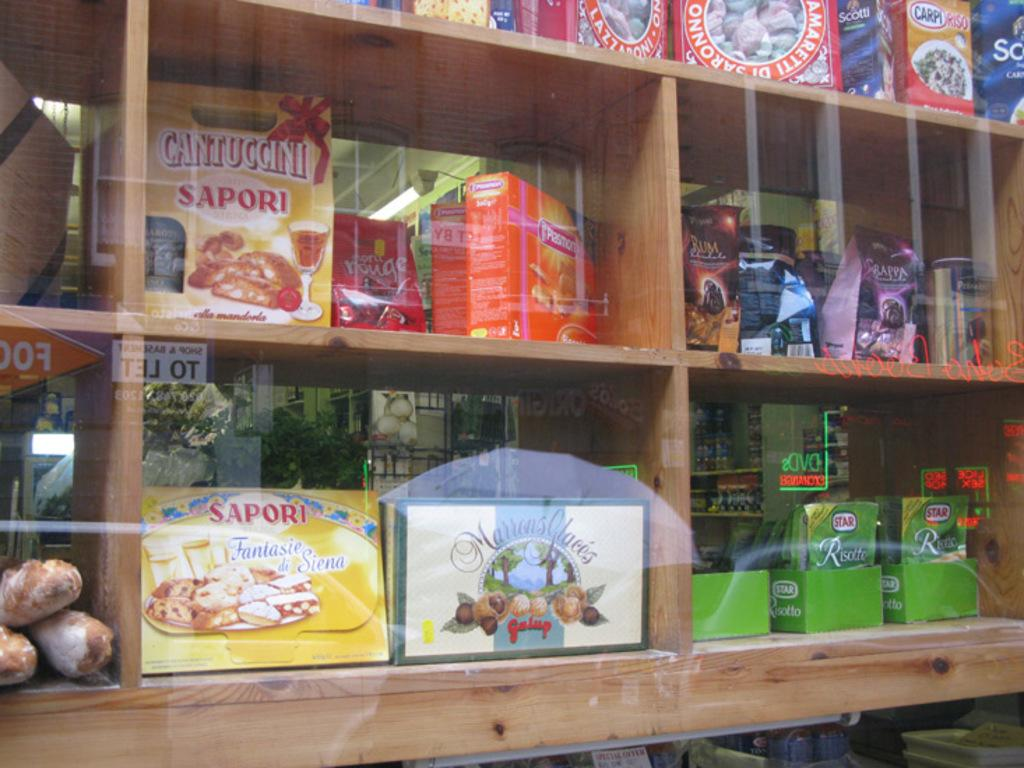What object is in the foreground of the image? There is a glass in the image. What can be seen behind the glass? Shelves are visible behind the glass. What items are on the shelves? There are boxes and packets on the shelves. What type of vegetation is in the background of the image? There is a plant in the background of the image. What type of meat is being served at the feast in the image? There is no feast or meat present in the image; it features a glass, shelves, boxes, packets, and a plant. 